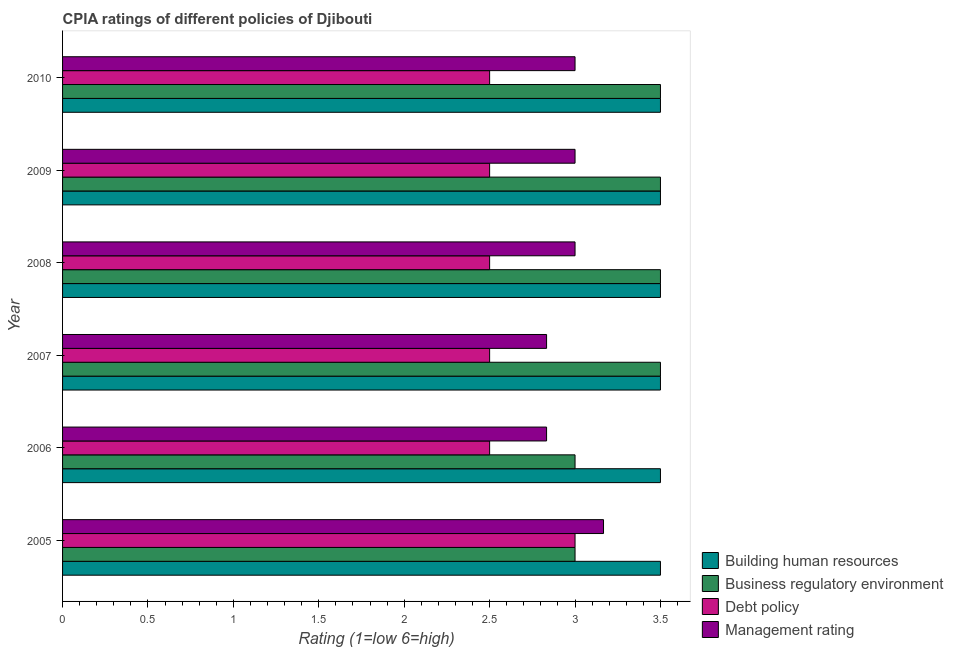How many different coloured bars are there?
Your response must be concise. 4. How many bars are there on the 3rd tick from the top?
Make the answer very short. 4. What is the label of the 3rd group of bars from the top?
Keep it short and to the point. 2008. What is the cpia rating of business regulatory environment in 2005?
Ensure brevity in your answer.  3. Across all years, what is the maximum cpia rating of debt policy?
Ensure brevity in your answer.  3. In which year was the cpia rating of building human resources minimum?
Give a very brief answer. 2005. What is the average cpia rating of business regulatory environment per year?
Offer a terse response. 3.33. In the year 2006, what is the difference between the cpia rating of management and cpia rating of debt policy?
Provide a succinct answer. 0.33. In how many years, is the cpia rating of building human resources greater than 2.5 ?
Give a very brief answer. 6. Is the difference between the cpia rating of debt policy in 2006 and 2009 greater than the difference between the cpia rating of management in 2006 and 2009?
Provide a short and direct response. Yes. What is the difference between the highest and the second highest cpia rating of management?
Give a very brief answer. 0.17. In how many years, is the cpia rating of management greater than the average cpia rating of management taken over all years?
Offer a very short reply. 4. Is the sum of the cpia rating of management in 2007 and 2008 greater than the maximum cpia rating of building human resources across all years?
Offer a very short reply. Yes. Is it the case that in every year, the sum of the cpia rating of management and cpia rating of business regulatory environment is greater than the sum of cpia rating of building human resources and cpia rating of debt policy?
Offer a very short reply. No. What does the 3rd bar from the top in 2005 represents?
Provide a succinct answer. Business regulatory environment. What does the 3rd bar from the bottom in 2007 represents?
Offer a very short reply. Debt policy. Is it the case that in every year, the sum of the cpia rating of building human resources and cpia rating of business regulatory environment is greater than the cpia rating of debt policy?
Your answer should be very brief. Yes. How many bars are there?
Your answer should be very brief. 24. How many years are there in the graph?
Your answer should be very brief. 6. What is the difference between two consecutive major ticks on the X-axis?
Provide a short and direct response. 0.5. Does the graph contain grids?
Provide a succinct answer. No. Where does the legend appear in the graph?
Give a very brief answer. Bottom right. How are the legend labels stacked?
Provide a short and direct response. Vertical. What is the title of the graph?
Your answer should be very brief. CPIA ratings of different policies of Djibouti. Does "Quality of logistic services" appear as one of the legend labels in the graph?
Provide a succinct answer. No. What is the label or title of the Y-axis?
Give a very brief answer. Year. What is the Rating (1=low 6=high) of Building human resources in 2005?
Your answer should be compact. 3.5. What is the Rating (1=low 6=high) in Business regulatory environment in 2005?
Offer a terse response. 3. What is the Rating (1=low 6=high) in Debt policy in 2005?
Ensure brevity in your answer.  3. What is the Rating (1=low 6=high) in Management rating in 2005?
Your answer should be compact. 3.17. What is the Rating (1=low 6=high) in Debt policy in 2006?
Your response must be concise. 2.5. What is the Rating (1=low 6=high) in Management rating in 2006?
Keep it short and to the point. 2.83. What is the Rating (1=low 6=high) in Building human resources in 2007?
Your response must be concise. 3.5. What is the Rating (1=low 6=high) in Management rating in 2007?
Your response must be concise. 2.83. What is the Rating (1=low 6=high) of Management rating in 2008?
Your answer should be very brief. 3. What is the Rating (1=low 6=high) in Building human resources in 2009?
Your response must be concise. 3.5. What is the Rating (1=low 6=high) in Business regulatory environment in 2009?
Give a very brief answer. 3.5. What is the Rating (1=low 6=high) of Building human resources in 2010?
Give a very brief answer. 3.5. What is the Rating (1=low 6=high) of Management rating in 2010?
Make the answer very short. 3. Across all years, what is the maximum Rating (1=low 6=high) of Building human resources?
Make the answer very short. 3.5. Across all years, what is the maximum Rating (1=low 6=high) of Management rating?
Ensure brevity in your answer.  3.17. Across all years, what is the minimum Rating (1=low 6=high) in Business regulatory environment?
Provide a succinct answer. 3. Across all years, what is the minimum Rating (1=low 6=high) in Management rating?
Provide a short and direct response. 2.83. What is the total Rating (1=low 6=high) of Management rating in the graph?
Offer a very short reply. 17.83. What is the difference between the Rating (1=low 6=high) of Debt policy in 2005 and that in 2006?
Provide a succinct answer. 0.5. What is the difference between the Rating (1=low 6=high) in Building human resources in 2005 and that in 2007?
Your answer should be compact. 0. What is the difference between the Rating (1=low 6=high) of Business regulatory environment in 2005 and that in 2007?
Provide a succinct answer. -0.5. What is the difference between the Rating (1=low 6=high) of Debt policy in 2005 and that in 2007?
Your answer should be very brief. 0.5. What is the difference between the Rating (1=low 6=high) in Management rating in 2005 and that in 2007?
Give a very brief answer. 0.33. What is the difference between the Rating (1=low 6=high) of Debt policy in 2005 and that in 2008?
Offer a terse response. 0.5. What is the difference between the Rating (1=low 6=high) of Management rating in 2005 and that in 2008?
Ensure brevity in your answer.  0.17. What is the difference between the Rating (1=low 6=high) in Debt policy in 2005 and that in 2009?
Your answer should be compact. 0.5. What is the difference between the Rating (1=low 6=high) in Building human resources in 2005 and that in 2010?
Provide a short and direct response. 0. What is the difference between the Rating (1=low 6=high) in Management rating in 2005 and that in 2010?
Ensure brevity in your answer.  0.17. What is the difference between the Rating (1=low 6=high) of Business regulatory environment in 2006 and that in 2008?
Offer a terse response. -0.5. What is the difference between the Rating (1=low 6=high) in Management rating in 2006 and that in 2008?
Your answer should be compact. -0.17. What is the difference between the Rating (1=low 6=high) in Business regulatory environment in 2006 and that in 2009?
Offer a terse response. -0.5. What is the difference between the Rating (1=low 6=high) in Management rating in 2006 and that in 2009?
Your answer should be compact. -0.17. What is the difference between the Rating (1=low 6=high) in Management rating in 2006 and that in 2010?
Your answer should be very brief. -0.17. What is the difference between the Rating (1=low 6=high) in Business regulatory environment in 2007 and that in 2008?
Ensure brevity in your answer.  0. What is the difference between the Rating (1=low 6=high) of Management rating in 2007 and that in 2008?
Provide a succinct answer. -0.17. What is the difference between the Rating (1=low 6=high) in Building human resources in 2007 and that in 2009?
Provide a succinct answer. 0. What is the difference between the Rating (1=low 6=high) of Debt policy in 2007 and that in 2009?
Make the answer very short. 0. What is the difference between the Rating (1=low 6=high) of Building human resources in 2008 and that in 2009?
Your answer should be compact. 0. What is the difference between the Rating (1=low 6=high) in Management rating in 2008 and that in 2009?
Provide a succinct answer. 0. What is the difference between the Rating (1=low 6=high) in Building human resources in 2008 and that in 2010?
Give a very brief answer. 0. What is the difference between the Rating (1=low 6=high) in Business regulatory environment in 2008 and that in 2010?
Provide a short and direct response. 0. What is the difference between the Rating (1=low 6=high) in Debt policy in 2008 and that in 2010?
Your answer should be compact. 0. What is the difference between the Rating (1=low 6=high) in Management rating in 2008 and that in 2010?
Make the answer very short. 0. What is the difference between the Rating (1=low 6=high) in Building human resources in 2005 and the Rating (1=low 6=high) in Business regulatory environment in 2006?
Keep it short and to the point. 0.5. What is the difference between the Rating (1=low 6=high) in Building human resources in 2005 and the Rating (1=low 6=high) in Management rating in 2006?
Offer a very short reply. 0.67. What is the difference between the Rating (1=low 6=high) of Building human resources in 2005 and the Rating (1=low 6=high) of Business regulatory environment in 2007?
Make the answer very short. 0. What is the difference between the Rating (1=low 6=high) of Building human resources in 2005 and the Rating (1=low 6=high) of Management rating in 2007?
Provide a succinct answer. 0.67. What is the difference between the Rating (1=low 6=high) of Business regulatory environment in 2005 and the Rating (1=low 6=high) of Management rating in 2007?
Your answer should be compact. 0.17. What is the difference between the Rating (1=low 6=high) of Debt policy in 2005 and the Rating (1=low 6=high) of Management rating in 2007?
Provide a succinct answer. 0.17. What is the difference between the Rating (1=low 6=high) of Building human resources in 2005 and the Rating (1=low 6=high) of Management rating in 2008?
Your answer should be compact. 0.5. What is the difference between the Rating (1=low 6=high) of Business regulatory environment in 2005 and the Rating (1=low 6=high) of Management rating in 2008?
Provide a succinct answer. 0. What is the difference between the Rating (1=low 6=high) in Building human resources in 2005 and the Rating (1=low 6=high) in Business regulatory environment in 2009?
Keep it short and to the point. 0. What is the difference between the Rating (1=low 6=high) of Building human resources in 2005 and the Rating (1=low 6=high) of Debt policy in 2009?
Offer a terse response. 1. What is the difference between the Rating (1=low 6=high) of Building human resources in 2005 and the Rating (1=low 6=high) of Management rating in 2009?
Provide a short and direct response. 0.5. What is the difference between the Rating (1=low 6=high) in Business regulatory environment in 2005 and the Rating (1=low 6=high) in Debt policy in 2009?
Offer a terse response. 0.5. What is the difference between the Rating (1=low 6=high) in Business regulatory environment in 2005 and the Rating (1=low 6=high) in Management rating in 2009?
Provide a short and direct response. 0. What is the difference between the Rating (1=low 6=high) in Debt policy in 2005 and the Rating (1=low 6=high) in Management rating in 2009?
Give a very brief answer. 0. What is the difference between the Rating (1=low 6=high) in Building human resources in 2005 and the Rating (1=low 6=high) in Debt policy in 2010?
Give a very brief answer. 1. What is the difference between the Rating (1=low 6=high) in Building human resources in 2005 and the Rating (1=low 6=high) in Management rating in 2010?
Keep it short and to the point. 0.5. What is the difference between the Rating (1=low 6=high) of Debt policy in 2005 and the Rating (1=low 6=high) of Management rating in 2010?
Keep it short and to the point. 0. What is the difference between the Rating (1=low 6=high) of Business regulatory environment in 2006 and the Rating (1=low 6=high) of Management rating in 2007?
Provide a succinct answer. 0.17. What is the difference between the Rating (1=low 6=high) of Business regulatory environment in 2006 and the Rating (1=low 6=high) of Debt policy in 2008?
Provide a succinct answer. 0.5. What is the difference between the Rating (1=low 6=high) of Business regulatory environment in 2006 and the Rating (1=low 6=high) of Management rating in 2008?
Your answer should be very brief. 0. What is the difference between the Rating (1=low 6=high) in Debt policy in 2006 and the Rating (1=low 6=high) in Management rating in 2008?
Give a very brief answer. -0.5. What is the difference between the Rating (1=low 6=high) of Building human resources in 2006 and the Rating (1=low 6=high) of Management rating in 2009?
Offer a terse response. 0.5. What is the difference between the Rating (1=low 6=high) in Business regulatory environment in 2006 and the Rating (1=low 6=high) in Management rating in 2009?
Your answer should be very brief. 0. What is the difference between the Rating (1=low 6=high) of Debt policy in 2006 and the Rating (1=low 6=high) of Management rating in 2009?
Offer a terse response. -0.5. What is the difference between the Rating (1=low 6=high) of Building human resources in 2006 and the Rating (1=low 6=high) of Business regulatory environment in 2010?
Give a very brief answer. 0. What is the difference between the Rating (1=low 6=high) of Building human resources in 2006 and the Rating (1=low 6=high) of Management rating in 2010?
Offer a very short reply. 0.5. What is the difference between the Rating (1=low 6=high) in Business regulatory environment in 2006 and the Rating (1=low 6=high) in Debt policy in 2010?
Give a very brief answer. 0.5. What is the difference between the Rating (1=low 6=high) of Debt policy in 2006 and the Rating (1=low 6=high) of Management rating in 2010?
Your response must be concise. -0.5. What is the difference between the Rating (1=low 6=high) in Building human resources in 2007 and the Rating (1=low 6=high) in Business regulatory environment in 2008?
Offer a very short reply. 0. What is the difference between the Rating (1=low 6=high) of Business regulatory environment in 2007 and the Rating (1=low 6=high) of Management rating in 2008?
Your answer should be compact. 0.5. What is the difference between the Rating (1=low 6=high) in Building human resources in 2007 and the Rating (1=low 6=high) in Business regulatory environment in 2009?
Provide a short and direct response. 0. What is the difference between the Rating (1=low 6=high) in Building human resources in 2007 and the Rating (1=low 6=high) in Debt policy in 2009?
Ensure brevity in your answer.  1. What is the difference between the Rating (1=low 6=high) in Business regulatory environment in 2007 and the Rating (1=low 6=high) in Debt policy in 2009?
Offer a very short reply. 1. What is the difference between the Rating (1=low 6=high) of Business regulatory environment in 2007 and the Rating (1=low 6=high) of Management rating in 2009?
Your response must be concise. 0.5. What is the difference between the Rating (1=low 6=high) in Debt policy in 2007 and the Rating (1=low 6=high) in Management rating in 2009?
Your answer should be very brief. -0.5. What is the difference between the Rating (1=low 6=high) in Building human resources in 2007 and the Rating (1=low 6=high) in Business regulatory environment in 2010?
Provide a short and direct response. 0. What is the difference between the Rating (1=low 6=high) of Building human resources in 2007 and the Rating (1=low 6=high) of Debt policy in 2010?
Provide a short and direct response. 1. What is the difference between the Rating (1=low 6=high) of Building human resources in 2007 and the Rating (1=low 6=high) of Management rating in 2010?
Your response must be concise. 0.5. What is the difference between the Rating (1=low 6=high) of Business regulatory environment in 2007 and the Rating (1=low 6=high) of Debt policy in 2010?
Keep it short and to the point. 1. What is the difference between the Rating (1=low 6=high) of Building human resources in 2008 and the Rating (1=low 6=high) of Management rating in 2009?
Offer a terse response. 0.5. What is the difference between the Rating (1=low 6=high) of Business regulatory environment in 2008 and the Rating (1=low 6=high) of Debt policy in 2009?
Offer a terse response. 1. What is the difference between the Rating (1=low 6=high) of Debt policy in 2008 and the Rating (1=low 6=high) of Management rating in 2009?
Your answer should be compact. -0.5. What is the difference between the Rating (1=low 6=high) of Building human resources in 2008 and the Rating (1=low 6=high) of Debt policy in 2010?
Your answer should be compact. 1. What is the difference between the Rating (1=low 6=high) of Building human resources in 2008 and the Rating (1=low 6=high) of Management rating in 2010?
Your answer should be very brief. 0.5. What is the difference between the Rating (1=low 6=high) in Business regulatory environment in 2008 and the Rating (1=low 6=high) in Management rating in 2010?
Your answer should be compact. 0.5. What is the difference between the Rating (1=low 6=high) in Building human resources in 2009 and the Rating (1=low 6=high) in Business regulatory environment in 2010?
Offer a terse response. 0. What is the difference between the Rating (1=low 6=high) of Business regulatory environment in 2009 and the Rating (1=low 6=high) of Debt policy in 2010?
Offer a terse response. 1. What is the average Rating (1=low 6=high) of Debt policy per year?
Ensure brevity in your answer.  2.58. What is the average Rating (1=low 6=high) of Management rating per year?
Make the answer very short. 2.97. In the year 2005, what is the difference between the Rating (1=low 6=high) in Building human resources and Rating (1=low 6=high) in Debt policy?
Provide a short and direct response. 0.5. In the year 2005, what is the difference between the Rating (1=low 6=high) in Business regulatory environment and Rating (1=low 6=high) in Debt policy?
Your answer should be very brief. 0. In the year 2006, what is the difference between the Rating (1=low 6=high) in Building human resources and Rating (1=low 6=high) in Business regulatory environment?
Keep it short and to the point. 0.5. In the year 2006, what is the difference between the Rating (1=low 6=high) of Building human resources and Rating (1=low 6=high) of Debt policy?
Provide a succinct answer. 1. In the year 2006, what is the difference between the Rating (1=low 6=high) of Building human resources and Rating (1=low 6=high) of Management rating?
Keep it short and to the point. 0.67. In the year 2006, what is the difference between the Rating (1=low 6=high) of Business regulatory environment and Rating (1=low 6=high) of Debt policy?
Your response must be concise. 0.5. In the year 2006, what is the difference between the Rating (1=low 6=high) of Business regulatory environment and Rating (1=low 6=high) of Management rating?
Keep it short and to the point. 0.17. In the year 2007, what is the difference between the Rating (1=low 6=high) of Building human resources and Rating (1=low 6=high) of Debt policy?
Your response must be concise. 1. In the year 2007, what is the difference between the Rating (1=low 6=high) in Building human resources and Rating (1=low 6=high) in Management rating?
Make the answer very short. 0.67. In the year 2007, what is the difference between the Rating (1=low 6=high) of Debt policy and Rating (1=low 6=high) of Management rating?
Offer a very short reply. -0.33. In the year 2008, what is the difference between the Rating (1=low 6=high) of Building human resources and Rating (1=low 6=high) of Management rating?
Your response must be concise. 0.5. In the year 2008, what is the difference between the Rating (1=low 6=high) in Business regulatory environment and Rating (1=low 6=high) in Debt policy?
Provide a short and direct response. 1. In the year 2008, what is the difference between the Rating (1=low 6=high) in Debt policy and Rating (1=low 6=high) in Management rating?
Give a very brief answer. -0.5. In the year 2009, what is the difference between the Rating (1=low 6=high) in Business regulatory environment and Rating (1=low 6=high) in Management rating?
Your response must be concise. 0.5. In the year 2009, what is the difference between the Rating (1=low 6=high) in Debt policy and Rating (1=low 6=high) in Management rating?
Provide a succinct answer. -0.5. In the year 2010, what is the difference between the Rating (1=low 6=high) in Building human resources and Rating (1=low 6=high) in Business regulatory environment?
Offer a terse response. 0. In the year 2010, what is the difference between the Rating (1=low 6=high) in Building human resources and Rating (1=low 6=high) in Debt policy?
Ensure brevity in your answer.  1. In the year 2010, what is the difference between the Rating (1=low 6=high) of Building human resources and Rating (1=low 6=high) of Management rating?
Keep it short and to the point. 0.5. In the year 2010, what is the difference between the Rating (1=low 6=high) of Business regulatory environment and Rating (1=low 6=high) of Debt policy?
Your answer should be compact. 1. In the year 2010, what is the difference between the Rating (1=low 6=high) in Business regulatory environment and Rating (1=low 6=high) in Management rating?
Provide a succinct answer. 0.5. In the year 2010, what is the difference between the Rating (1=low 6=high) of Debt policy and Rating (1=low 6=high) of Management rating?
Offer a terse response. -0.5. What is the ratio of the Rating (1=low 6=high) in Business regulatory environment in 2005 to that in 2006?
Provide a succinct answer. 1. What is the ratio of the Rating (1=low 6=high) of Management rating in 2005 to that in 2006?
Provide a short and direct response. 1.12. What is the ratio of the Rating (1=low 6=high) in Building human resources in 2005 to that in 2007?
Your answer should be compact. 1. What is the ratio of the Rating (1=low 6=high) in Business regulatory environment in 2005 to that in 2007?
Make the answer very short. 0.86. What is the ratio of the Rating (1=low 6=high) of Debt policy in 2005 to that in 2007?
Make the answer very short. 1.2. What is the ratio of the Rating (1=low 6=high) of Management rating in 2005 to that in 2007?
Your response must be concise. 1.12. What is the ratio of the Rating (1=low 6=high) in Business regulatory environment in 2005 to that in 2008?
Offer a terse response. 0.86. What is the ratio of the Rating (1=low 6=high) in Management rating in 2005 to that in 2008?
Provide a short and direct response. 1.06. What is the ratio of the Rating (1=low 6=high) of Building human resources in 2005 to that in 2009?
Ensure brevity in your answer.  1. What is the ratio of the Rating (1=low 6=high) of Business regulatory environment in 2005 to that in 2009?
Keep it short and to the point. 0.86. What is the ratio of the Rating (1=low 6=high) in Debt policy in 2005 to that in 2009?
Your response must be concise. 1.2. What is the ratio of the Rating (1=low 6=high) of Management rating in 2005 to that in 2009?
Give a very brief answer. 1.06. What is the ratio of the Rating (1=low 6=high) of Building human resources in 2005 to that in 2010?
Provide a short and direct response. 1. What is the ratio of the Rating (1=low 6=high) in Management rating in 2005 to that in 2010?
Keep it short and to the point. 1.06. What is the ratio of the Rating (1=low 6=high) in Management rating in 2006 to that in 2007?
Your answer should be very brief. 1. What is the ratio of the Rating (1=low 6=high) of Business regulatory environment in 2006 to that in 2008?
Make the answer very short. 0.86. What is the ratio of the Rating (1=low 6=high) of Debt policy in 2006 to that in 2008?
Give a very brief answer. 1. What is the ratio of the Rating (1=low 6=high) in Building human resources in 2006 to that in 2010?
Keep it short and to the point. 1. What is the ratio of the Rating (1=low 6=high) of Debt policy in 2006 to that in 2010?
Your answer should be very brief. 1. What is the ratio of the Rating (1=low 6=high) in Management rating in 2006 to that in 2010?
Provide a short and direct response. 0.94. What is the ratio of the Rating (1=low 6=high) of Building human resources in 2007 to that in 2008?
Your answer should be very brief. 1. What is the ratio of the Rating (1=low 6=high) of Business regulatory environment in 2007 to that in 2008?
Ensure brevity in your answer.  1. What is the ratio of the Rating (1=low 6=high) of Business regulatory environment in 2007 to that in 2009?
Keep it short and to the point. 1. What is the ratio of the Rating (1=low 6=high) of Debt policy in 2007 to that in 2009?
Provide a succinct answer. 1. What is the ratio of the Rating (1=low 6=high) in Management rating in 2007 to that in 2009?
Give a very brief answer. 0.94. What is the ratio of the Rating (1=low 6=high) of Debt policy in 2007 to that in 2010?
Offer a terse response. 1. What is the ratio of the Rating (1=low 6=high) of Management rating in 2007 to that in 2010?
Offer a terse response. 0.94. What is the ratio of the Rating (1=low 6=high) of Building human resources in 2008 to that in 2010?
Offer a very short reply. 1. What is the ratio of the Rating (1=low 6=high) of Business regulatory environment in 2008 to that in 2010?
Give a very brief answer. 1. What is the ratio of the Rating (1=low 6=high) in Business regulatory environment in 2009 to that in 2010?
Your answer should be compact. 1. What is the difference between the highest and the second highest Rating (1=low 6=high) in Building human resources?
Keep it short and to the point. 0. What is the difference between the highest and the second highest Rating (1=low 6=high) in Business regulatory environment?
Your response must be concise. 0. What is the difference between the highest and the second highest Rating (1=low 6=high) of Management rating?
Keep it short and to the point. 0.17. What is the difference between the highest and the lowest Rating (1=low 6=high) of Business regulatory environment?
Provide a short and direct response. 0.5. What is the difference between the highest and the lowest Rating (1=low 6=high) of Debt policy?
Offer a very short reply. 0.5. What is the difference between the highest and the lowest Rating (1=low 6=high) in Management rating?
Provide a short and direct response. 0.33. 